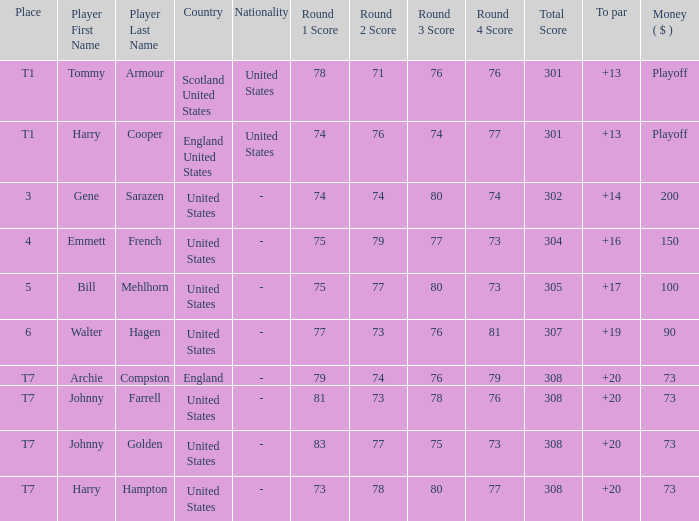Which country possesses a subpar less than 19 and a score of 75-79-77-73=304? United States. 